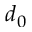<formula> <loc_0><loc_0><loc_500><loc_500>d _ { 0 }</formula> 